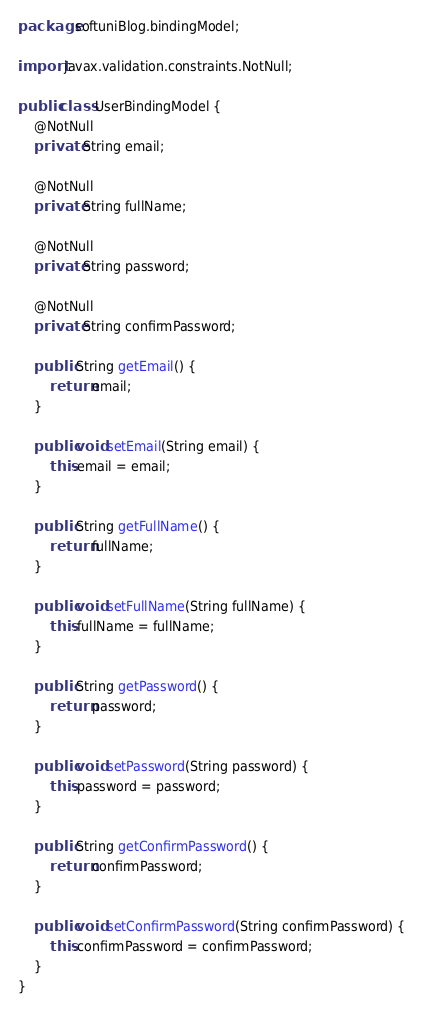<code> <loc_0><loc_0><loc_500><loc_500><_Java_>package softuniBlog.bindingModel;

import javax.validation.constraints.NotNull;

public class UserBindingModel {
    @NotNull
    private String email;

    @NotNull
    private String fullName;

    @NotNull
    private String password;

    @NotNull
    private String confirmPassword;

    public String getEmail() {
        return email;
    }

    public void setEmail(String email) {
        this.email = email;
    }

    public String getFullName() {
        return fullName;
    }

    public void setFullName(String fullName) {
        this.fullName = fullName;
    }

    public String getPassword() {
        return password;
    }

    public void setPassword(String password) {
        this.password = password;
    }

    public String getConfirmPassword() {
        return confirmPassword;
    }

    public void setConfirmPassword(String confirmPassword) {
        this.confirmPassword = confirmPassword;
    }
}</code> 